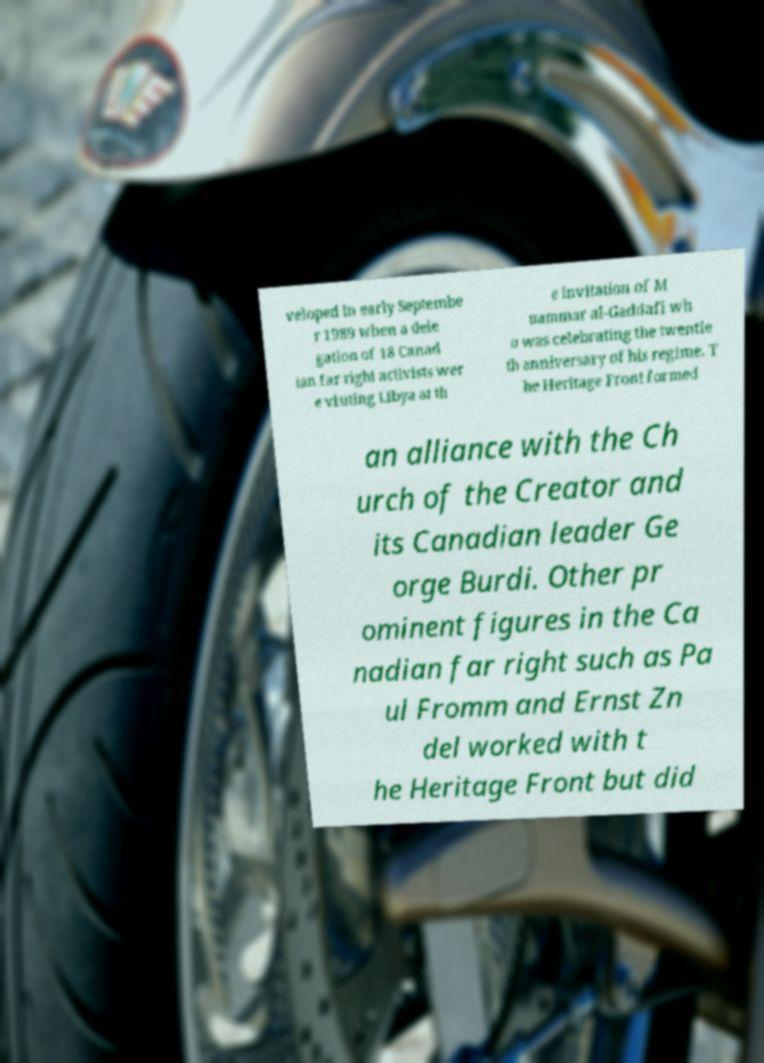Can you read and provide the text displayed in the image?This photo seems to have some interesting text. Can you extract and type it out for me? veloped in early Septembe r 1989 when a dele gation of 18 Canad ian far right activists wer e visiting Libya at th e invitation of M uammar al-Gaddafi wh o was celebrating the twentie th anniversary of his regime. T he Heritage Front formed an alliance with the Ch urch of the Creator and its Canadian leader Ge orge Burdi. Other pr ominent figures in the Ca nadian far right such as Pa ul Fromm and Ernst Zn del worked with t he Heritage Front but did 